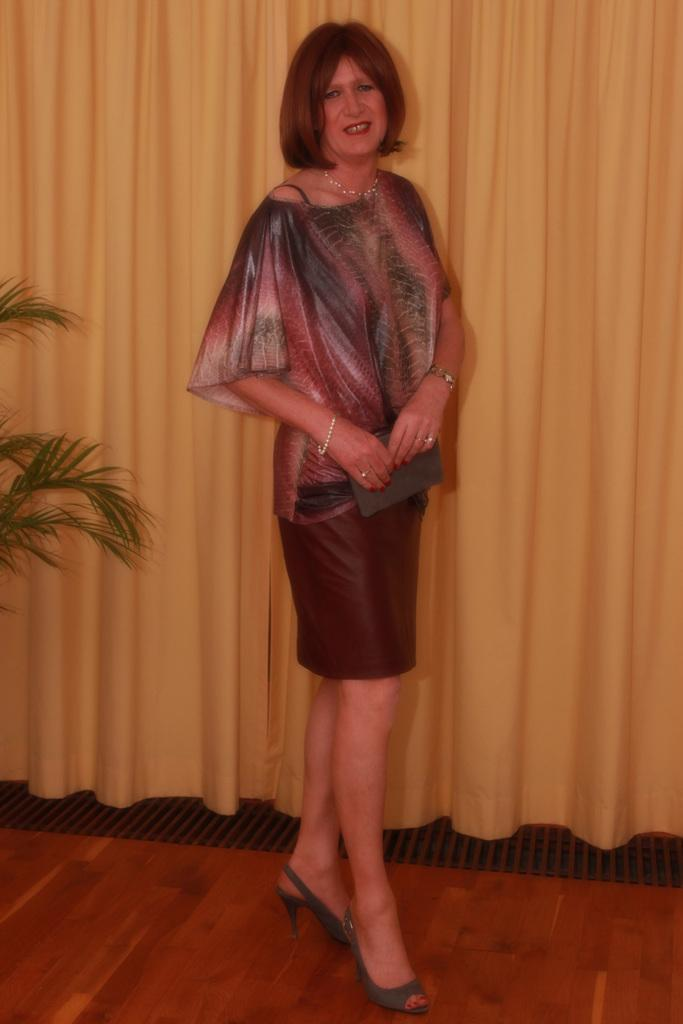What is the main subject of the image? There is a person standing in the image. Can you describe the person's attire? The person is wearing clothes. What type of vegetation is visible on the left side of the image? There are leaves on the left side of the image. What can be seen in the background of the image? There are curtains in the background of the image. What type of record is the person holding in the image? There is no record present in the image; the person is not holding anything. How many sisters are visible in the image? There are no sisters present in the image; only one person is visible. 